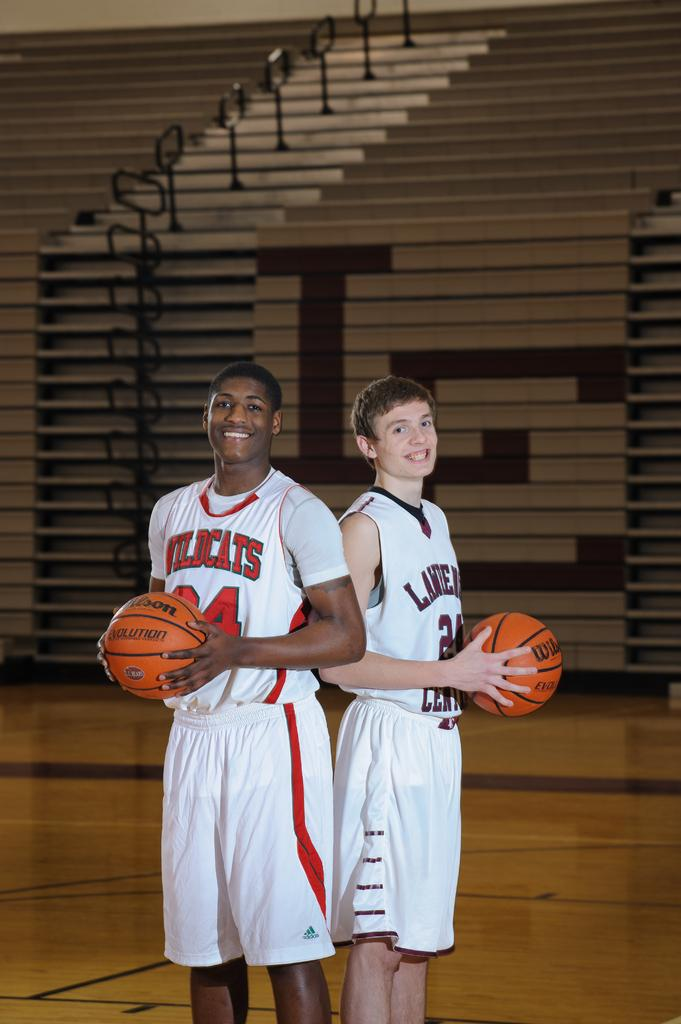<image>
Write a terse but informative summary of the picture. two basket ball players one is wearing wildcats jersey 